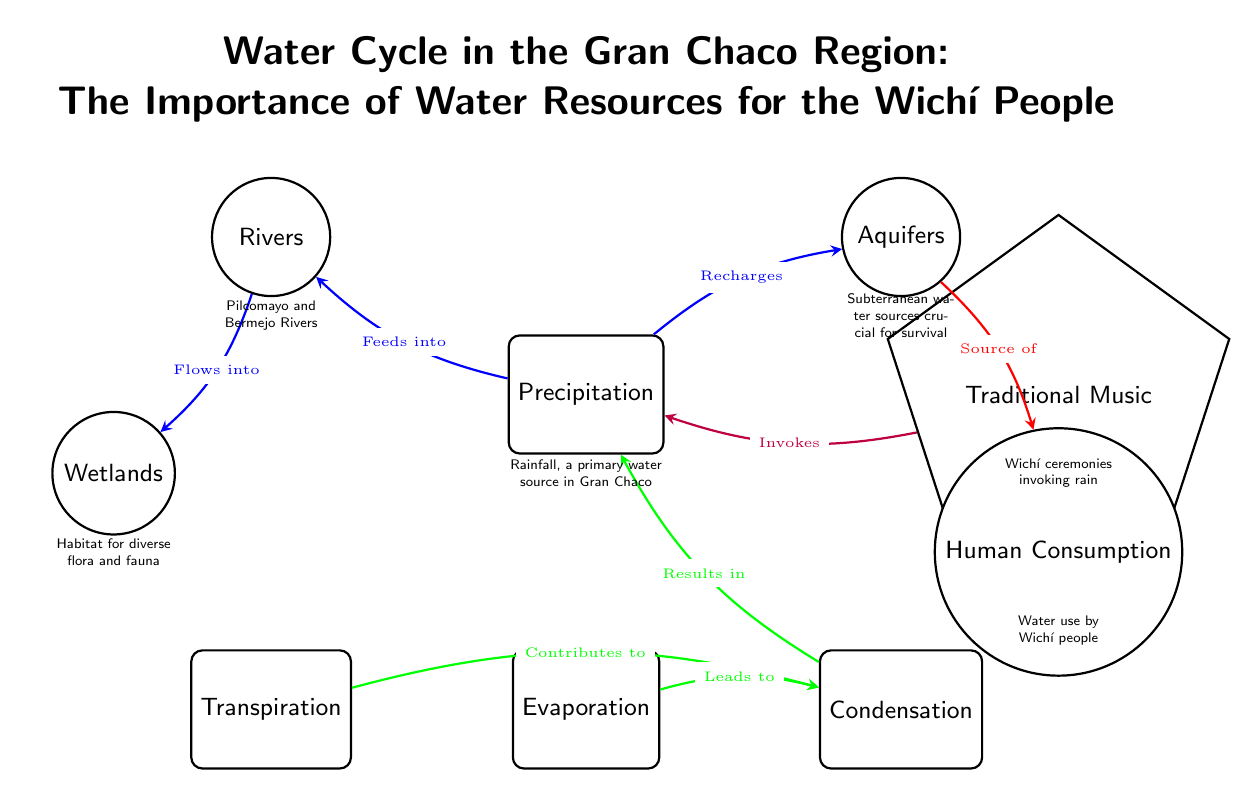What are the two primary water sources mentioned in the diagram? The diagram identifies "Rivers" and "Aquifers" as the two primary water sources for the Wichí people, represented as nodes associated with water resources.
Answer: Rivers and Aquifers What does evaporation contribute to in the water cycle? The diagram shows that "Evaporation" contributes to "Condensation", indicating its role in the water cycle process within the Gran Chaco region.
Answer: Condensation How many water bodies are illustrated in the diagram? There are three water bodies depicted in the diagram: "Rivers," "Aquifers," and "Wetlands." By counting each of these nodes, we find a total of three.
Answer: 3 What human activity is directly connected to aquifers in the diagram? The diagram indicates that "Human Consumption" is a direct result derived from "Aquifers," showing the vital connection between groundwater and the Wichí people's water use.
Answer: Human Consumption What cultural practice is represented in the diagram and how does it relate to precipitation? The "Traditional Music" node is connected to "Precipitation," indicating that Wichí ceremonies invoking rain are an important cultural practice related to water resources.
Answer: Traditional Music What leads to condensation in the water cycle according to the diagram? "Transpiration" and "Evaporation" are indicated to lead to "Condensation" in the water cycle, suggesting these processes are essential contributors to the formation of clouds and subsequent rainfall.
Answer: Transpiration and Evaporation How does precipitation affect rivers in the Gran Chaco region? The diagram states that "Precipitation" feeds into "Rivers," establishing a direct link between rainfall and the flow of water in river systems.
Answer: Feeds into What type of environment is created by the wetlands according to the diagram? The diagram notes that "Wetlands" are a habitat for diverse flora and fauna, illustrating the ecological importance of these areas in the Gran Chaco region.
Answer: Habitat for diverse flora and fauna Which node in the diagram is associated with the invocation of rain? The node "Traditional Music" is specifically mentioned to invoke "Precipitation," indicating its cultural significance related to water.
Answer: Traditional Music 